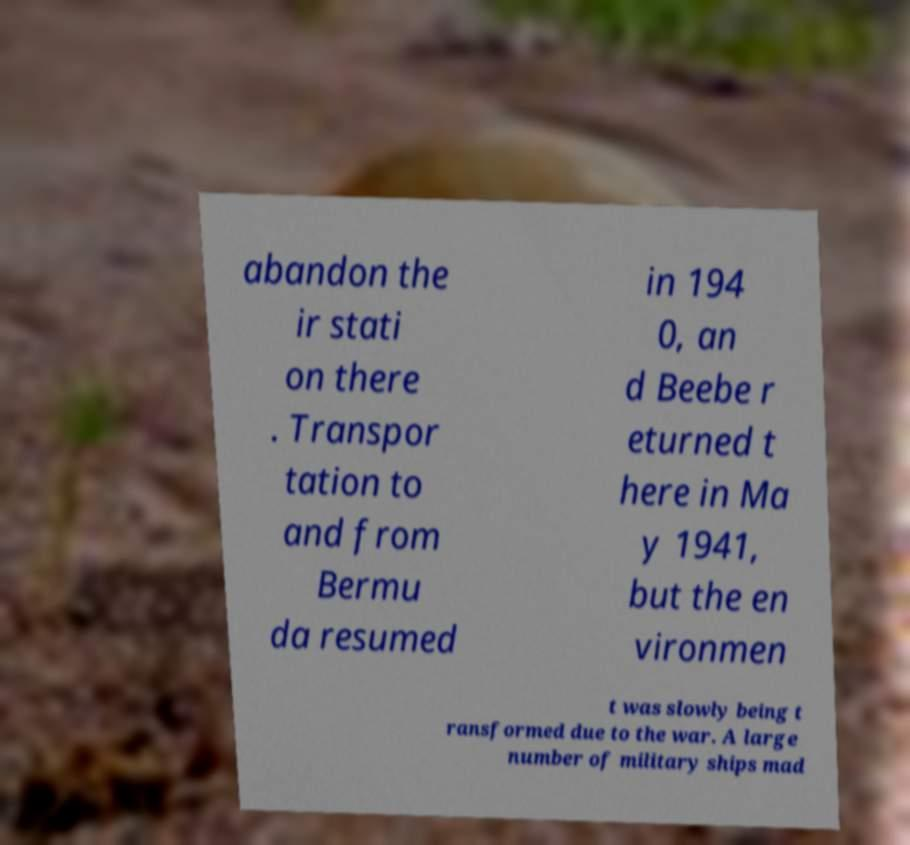What messages or text are displayed in this image? I need them in a readable, typed format. abandon the ir stati on there . Transpor tation to and from Bermu da resumed in 194 0, an d Beebe r eturned t here in Ma y 1941, but the en vironmen t was slowly being t ransformed due to the war. A large number of military ships mad 